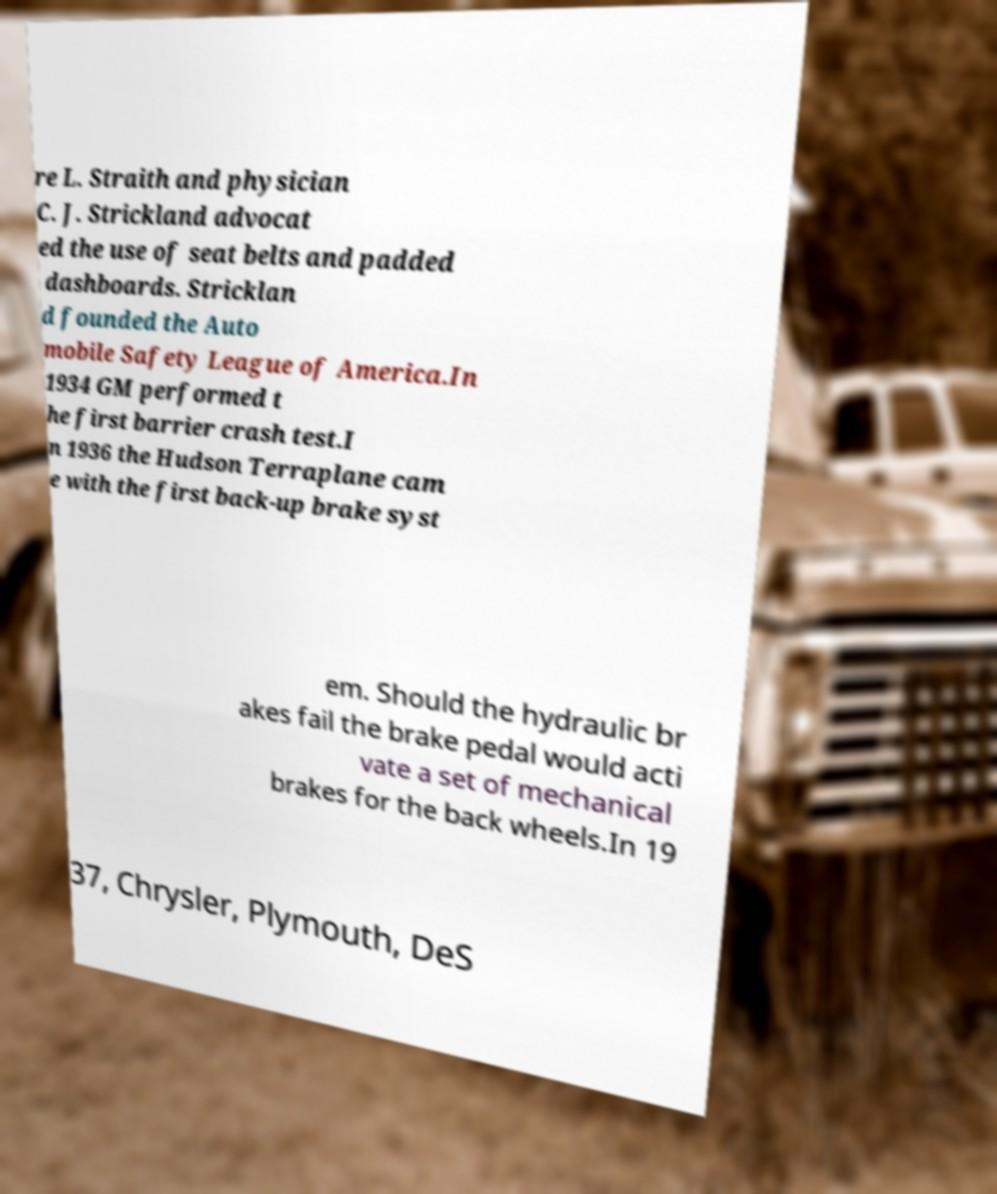Please read and relay the text visible in this image. What does it say? re L. Straith and physician C. J. Strickland advocat ed the use of seat belts and padded dashboards. Stricklan d founded the Auto mobile Safety League of America.In 1934 GM performed t he first barrier crash test.I n 1936 the Hudson Terraplane cam e with the first back-up brake syst em. Should the hydraulic br akes fail the brake pedal would acti vate a set of mechanical brakes for the back wheels.In 19 37, Chrysler, Plymouth, DeS 